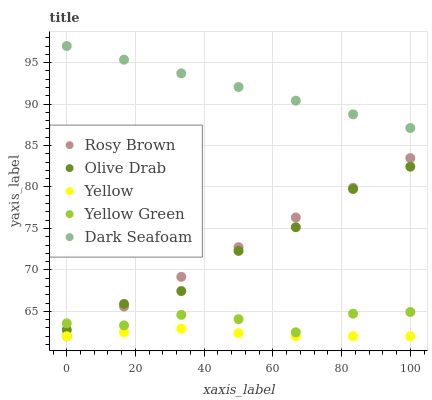Does Yellow have the minimum area under the curve?
Answer yes or no. Yes. Does Dark Seafoam have the maximum area under the curve?
Answer yes or no. Yes. Does Rosy Brown have the minimum area under the curve?
Answer yes or no. No. Does Rosy Brown have the maximum area under the curve?
Answer yes or no. No. Is Dark Seafoam the smoothest?
Answer yes or no. Yes. Is Olive Drab the roughest?
Answer yes or no. Yes. Is Rosy Brown the smoothest?
Answer yes or no. No. Is Rosy Brown the roughest?
Answer yes or no. No. Does Rosy Brown have the lowest value?
Answer yes or no. Yes. Does Olive Drab have the lowest value?
Answer yes or no. No. Does Dark Seafoam have the highest value?
Answer yes or no. Yes. Does Rosy Brown have the highest value?
Answer yes or no. No. Is Yellow Green less than Dark Seafoam?
Answer yes or no. Yes. Is Olive Drab greater than Yellow?
Answer yes or no. Yes. Does Rosy Brown intersect Olive Drab?
Answer yes or no. Yes. Is Rosy Brown less than Olive Drab?
Answer yes or no. No. Is Rosy Brown greater than Olive Drab?
Answer yes or no. No. Does Yellow Green intersect Dark Seafoam?
Answer yes or no. No. 